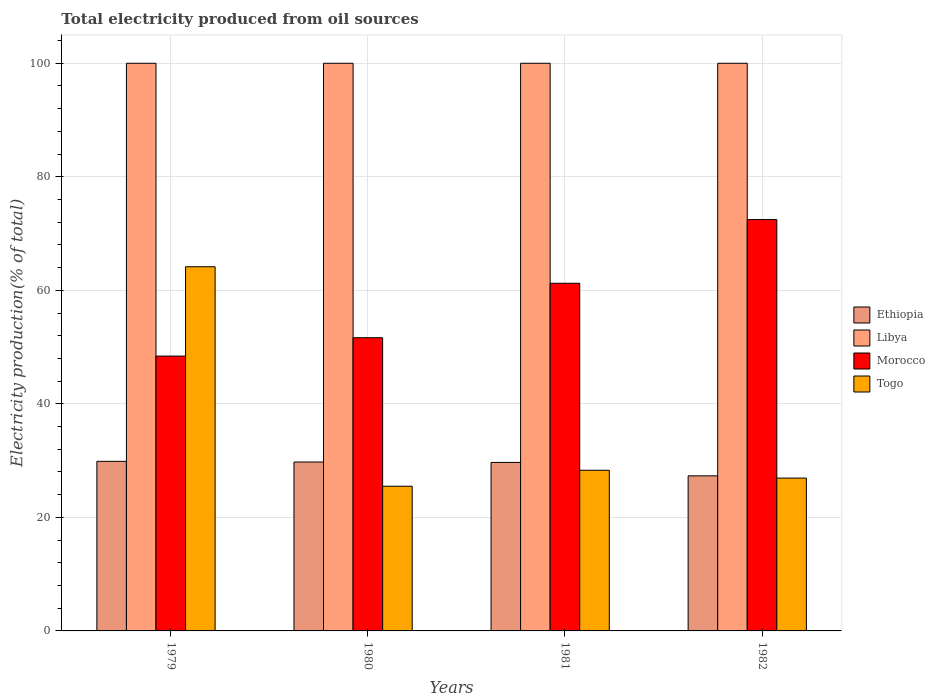How many different coloured bars are there?
Provide a short and direct response. 4. How many groups of bars are there?
Provide a short and direct response. 4. What is the label of the 3rd group of bars from the left?
Offer a terse response. 1981. What is the total electricity produced in Libya in 1980?
Make the answer very short. 100. Across all years, what is the minimum total electricity produced in Morocco?
Provide a succinct answer. 48.41. In which year was the total electricity produced in Togo maximum?
Give a very brief answer. 1979. In which year was the total electricity produced in Libya minimum?
Give a very brief answer. 1979. What is the total total electricity produced in Togo in the graph?
Your answer should be very brief. 144.87. What is the difference between the total electricity produced in Ethiopia in 1979 and that in 1980?
Provide a succinct answer. 0.12. What is the difference between the total electricity produced in Morocco in 1979 and the total electricity produced in Libya in 1980?
Ensure brevity in your answer.  -51.59. In the year 1982, what is the difference between the total electricity produced in Libya and total electricity produced in Togo?
Your answer should be very brief. 73.08. In how many years, is the total electricity produced in Togo greater than 20 %?
Your answer should be very brief. 4. What is the ratio of the total electricity produced in Ethiopia in 1981 to that in 1982?
Give a very brief answer. 1.09. Is the total electricity produced in Ethiopia in 1979 less than that in 1982?
Provide a short and direct response. No. In how many years, is the total electricity produced in Morocco greater than the average total electricity produced in Morocco taken over all years?
Offer a terse response. 2. Is it the case that in every year, the sum of the total electricity produced in Togo and total electricity produced in Ethiopia is greater than the sum of total electricity produced in Libya and total electricity produced in Morocco?
Give a very brief answer. No. What does the 1st bar from the left in 1979 represents?
Your answer should be compact. Ethiopia. What does the 4th bar from the right in 1980 represents?
Your answer should be compact. Ethiopia. How many bars are there?
Provide a succinct answer. 16. How many years are there in the graph?
Keep it short and to the point. 4. What is the difference between two consecutive major ticks on the Y-axis?
Provide a succinct answer. 20. How many legend labels are there?
Ensure brevity in your answer.  4. What is the title of the graph?
Your response must be concise. Total electricity produced from oil sources. What is the label or title of the Y-axis?
Offer a very short reply. Electricity production(% of total). What is the Electricity production(% of total) of Ethiopia in 1979?
Your answer should be very brief. 29.87. What is the Electricity production(% of total) in Libya in 1979?
Ensure brevity in your answer.  100. What is the Electricity production(% of total) of Morocco in 1979?
Your answer should be compact. 48.41. What is the Electricity production(% of total) in Togo in 1979?
Your answer should be very brief. 64.15. What is the Electricity production(% of total) in Ethiopia in 1980?
Ensure brevity in your answer.  29.75. What is the Electricity production(% of total) in Morocco in 1980?
Your answer should be compact. 51.65. What is the Electricity production(% of total) in Togo in 1980?
Offer a very short reply. 25.49. What is the Electricity production(% of total) in Ethiopia in 1981?
Provide a succinct answer. 29.68. What is the Electricity production(% of total) of Libya in 1981?
Offer a terse response. 100. What is the Electricity production(% of total) in Morocco in 1981?
Your answer should be very brief. 61.24. What is the Electricity production(% of total) in Togo in 1981?
Ensure brevity in your answer.  28.3. What is the Electricity production(% of total) of Ethiopia in 1982?
Provide a short and direct response. 27.32. What is the Electricity production(% of total) in Morocco in 1982?
Provide a short and direct response. 72.47. What is the Electricity production(% of total) in Togo in 1982?
Give a very brief answer. 26.92. Across all years, what is the maximum Electricity production(% of total) in Ethiopia?
Your answer should be very brief. 29.87. Across all years, what is the maximum Electricity production(% of total) of Libya?
Offer a very short reply. 100. Across all years, what is the maximum Electricity production(% of total) in Morocco?
Ensure brevity in your answer.  72.47. Across all years, what is the maximum Electricity production(% of total) of Togo?
Make the answer very short. 64.15. Across all years, what is the minimum Electricity production(% of total) in Ethiopia?
Provide a succinct answer. 27.32. Across all years, what is the minimum Electricity production(% of total) in Libya?
Your answer should be very brief. 100. Across all years, what is the minimum Electricity production(% of total) in Morocco?
Ensure brevity in your answer.  48.41. Across all years, what is the minimum Electricity production(% of total) in Togo?
Your answer should be very brief. 25.49. What is the total Electricity production(% of total) of Ethiopia in the graph?
Offer a very short reply. 116.62. What is the total Electricity production(% of total) of Morocco in the graph?
Offer a terse response. 233.77. What is the total Electricity production(% of total) of Togo in the graph?
Ensure brevity in your answer.  144.87. What is the difference between the Electricity production(% of total) in Ethiopia in 1979 and that in 1980?
Offer a terse response. 0.12. What is the difference between the Electricity production(% of total) in Libya in 1979 and that in 1980?
Give a very brief answer. 0. What is the difference between the Electricity production(% of total) of Morocco in 1979 and that in 1980?
Your response must be concise. -3.23. What is the difference between the Electricity production(% of total) in Togo in 1979 and that in 1980?
Your answer should be very brief. 38.66. What is the difference between the Electricity production(% of total) of Ethiopia in 1979 and that in 1981?
Your answer should be compact. 0.19. What is the difference between the Electricity production(% of total) of Libya in 1979 and that in 1981?
Provide a succinct answer. 0. What is the difference between the Electricity production(% of total) in Morocco in 1979 and that in 1981?
Your answer should be compact. -12.83. What is the difference between the Electricity production(% of total) in Togo in 1979 and that in 1981?
Your response must be concise. 35.85. What is the difference between the Electricity production(% of total) of Ethiopia in 1979 and that in 1982?
Keep it short and to the point. 2.55. What is the difference between the Electricity production(% of total) of Libya in 1979 and that in 1982?
Provide a succinct answer. 0. What is the difference between the Electricity production(% of total) in Morocco in 1979 and that in 1982?
Your answer should be very brief. -24.05. What is the difference between the Electricity production(% of total) of Togo in 1979 and that in 1982?
Your answer should be compact. 37.23. What is the difference between the Electricity production(% of total) in Ethiopia in 1980 and that in 1981?
Make the answer very short. 0.07. What is the difference between the Electricity production(% of total) in Libya in 1980 and that in 1981?
Your answer should be very brief. 0. What is the difference between the Electricity production(% of total) of Morocco in 1980 and that in 1981?
Make the answer very short. -9.59. What is the difference between the Electricity production(% of total) in Togo in 1980 and that in 1981?
Keep it short and to the point. -2.81. What is the difference between the Electricity production(% of total) of Ethiopia in 1980 and that in 1982?
Offer a terse response. 2.44. What is the difference between the Electricity production(% of total) in Libya in 1980 and that in 1982?
Your response must be concise. 0. What is the difference between the Electricity production(% of total) in Morocco in 1980 and that in 1982?
Provide a succinct answer. -20.82. What is the difference between the Electricity production(% of total) in Togo in 1980 and that in 1982?
Make the answer very short. -1.43. What is the difference between the Electricity production(% of total) of Ethiopia in 1981 and that in 1982?
Ensure brevity in your answer.  2.36. What is the difference between the Electricity production(% of total) of Libya in 1981 and that in 1982?
Ensure brevity in your answer.  0. What is the difference between the Electricity production(% of total) in Morocco in 1981 and that in 1982?
Provide a short and direct response. -11.22. What is the difference between the Electricity production(% of total) in Togo in 1981 and that in 1982?
Keep it short and to the point. 1.38. What is the difference between the Electricity production(% of total) in Ethiopia in 1979 and the Electricity production(% of total) in Libya in 1980?
Provide a succinct answer. -70.13. What is the difference between the Electricity production(% of total) of Ethiopia in 1979 and the Electricity production(% of total) of Morocco in 1980?
Your answer should be very brief. -21.78. What is the difference between the Electricity production(% of total) of Ethiopia in 1979 and the Electricity production(% of total) of Togo in 1980?
Make the answer very short. 4.38. What is the difference between the Electricity production(% of total) in Libya in 1979 and the Electricity production(% of total) in Morocco in 1980?
Make the answer very short. 48.35. What is the difference between the Electricity production(% of total) in Libya in 1979 and the Electricity production(% of total) in Togo in 1980?
Offer a very short reply. 74.51. What is the difference between the Electricity production(% of total) of Morocco in 1979 and the Electricity production(% of total) of Togo in 1980?
Your response must be concise. 22.92. What is the difference between the Electricity production(% of total) of Ethiopia in 1979 and the Electricity production(% of total) of Libya in 1981?
Your answer should be compact. -70.13. What is the difference between the Electricity production(% of total) in Ethiopia in 1979 and the Electricity production(% of total) in Morocco in 1981?
Your answer should be very brief. -31.37. What is the difference between the Electricity production(% of total) of Ethiopia in 1979 and the Electricity production(% of total) of Togo in 1981?
Provide a short and direct response. 1.57. What is the difference between the Electricity production(% of total) in Libya in 1979 and the Electricity production(% of total) in Morocco in 1981?
Offer a terse response. 38.76. What is the difference between the Electricity production(% of total) of Libya in 1979 and the Electricity production(% of total) of Togo in 1981?
Ensure brevity in your answer.  71.7. What is the difference between the Electricity production(% of total) of Morocco in 1979 and the Electricity production(% of total) of Togo in 1981?
Provide a short and direct response. 20.11. What is the difference between the Electricity production(% of total) of Ethiopia in 1979 and the Electricity production(% of total) of Libya in 1982?
Make the answer very short. -70.13. What is the difference between the Electricity production(% of total) of Ethiopia in 1979 and the Electricity production(% of total) of Morocco in 1982?
Keep it short and to the point. -42.59. What is the difference between the Electricity production(% of total) in Ethiopia in 1979 and the Electricity production(% of total) in Togo in 1982?
Provide a succinct answer. 2.95. What is the difference between the Electricity production(% of total) in Libya in 1979 and the Electricity production(% of total) in Morocco in 1982?
Make the answer very short. 27.53. What is the difference between the Electricity production(% of total) of Libya in 1979 and the Electricity production(% of total) of Togo in 1982?
Offer a terse response. 73.08. What is the difference between the Electricity production(% of total) of Morocco in 1979 and the Electricity production(% of total) of Togo in 1982?
Provide a succinct answer. 21.49. What is the difference between the Electricity production(% of total) in Ethiopia in 1980 and the Electricity production(% of total) in Libya in 1981?
Keep it short and to the point. -70.25. What is the difference between the Electricity production(% of total) in Ethiopia in 1980 and the Electricity production(% of total) in Morocco in 1981?
Give a very brief answer. -31.49. What is the difference between the Electricity production(% of total) in Ethiopia in 1980 and the Electricity production(% of total) in Togo in 1981?
Offer a very short reply. 1.45. What is the difference between the Electricity production(% of total) in Libya in 1980 and the Electricity production(% of total) in Morocco in 1981?
Your response must be concise. 38.76. What is the difference between the Electricity production(% of total) in Libya in 1980 and the Electricity production(% of total) in Togo in 1981?
Offer a very short reply. 71.7. What is the difference between the Electricity production(% of total) in Morocco in 1980 and the Electricity production(% of total) in Togo in 1981?
Make the answer very short. 23.35. What is the difference between the Electricity production(% of total) in Ethiopia in 1980 and the Electricity production(% of total) in Libya in 1982?
Offer a terse response. -70.25. What is the difference between the Electricity production(% of total) in Ethiopia in 1980 and the Electricity production(% of total) in Morocco in 1982?
Provide a succinct answer. -42.71. What is the difference between the Electricity production(% of total) of Ethiopia in 1980 and the Electricity production(% of total) of Togo in 1982?
Provide a short and direct response. 2.83. What is the difference between the Electricity production(% of total) of Libya in 1980 and the Electricity production(% of total) of Morocco in 1982?
Provide a short and direct response. 27.53. What is the difference between the Electricity production(% of total) of Libya in 1980 and the Electricity production(% of total) of Togo in 1982?
Your answer should be compact. 73.08. What is the difference between the Electricity production(% of total) of Morocco in 1980 and the Electricity production(% of total) of Togo in 1982?
Offer a very short reply. 24.73. What is the difference between the Electricity production(% of total) in Ethiopia in 1981 and the Electricity production(% of total) in Libya in 1982?
Keep it short and to the point. -70.32. What is the difference between the Electricity production(% of total) in Ethiopia in 1981 and the Electricity production(% of total) in Morocco in 1982?
Provide a succinct answer. -42.78. What is the difference between the Electricity production(% of total) of Ethiopia in 1981 and the Electricity production(% of total) of Togo in 1982?
Your response must be concise. 2.76. What is the difference between the Electricity production(% of total) in Libya in 1981 and the Electricity production(% of total) in Morocco in 1982?
Give a very brief answer. 27.53. What is the difference between the Electricity production(% of total) in Libya in 1981 and the Electricity production(% of total) in Togo in 1982?
Your answer should be compact. 73.08. What is the difference between the Electricity production(% of total) of Morocco in 1981 and the Electricity production(% of total) of Togo in 1982?
Provide a succinct answer. 34.32. What is the average Electricity production(% of total) of Ethiopia per year?
Your answer should be very brief. 29.16. What is the average Electricity production(% of total) in Morocco per year?
Ensure brevity in your answer.  58.44. What is the average Electricity production(% of total) of Togo per year?
Your answer should be very brief. 36.22. In the year 1979, what is the difference between the Electricity production(% of total) in Ethiopia and Electricity production(% of total) in Libya?
Make the answer very short. -70.13. In the year 1979, what is the difference between the Electricity production(% of total) in Ethiopia and Electricity production(% of total) in Morocco?
Ensure brevity in your answer.  -18.54. In the year 1979, what is the difference between the Electricity production(% of total) of Ethiopia and Electricity production(% of total) of Togo?
Your response must be concise. -34.28. In the year 1979, what is the difference between the Electricity production(% of total) of Libya and Electricity production(% of total) of Morocco?
Keep it short and to the point. 51.59. In the year 1979, what is the difference between the Electricity production(% of total) of Libya and Electricity production(% of total) of Togo?
Provide a succinct answer. 35.85. In the year 1979, what is the difference between the Electricity production(% of total) of Morocco and Electricity production(% of total) of Togo?
Your answer should be compact. -15.74. In the year 1980, what is the difference between the Electricity production(% of total) of Ethiopia and Electricity production(% of total) of Libya?
Offer a very short reply. -70.25. In the year 1980, what is the difference between the Electricity production(% of total) of Ethiopia and Electricity production(% of total) of Morocco?
Your answer should be compact. -21.9. In the year 1980, what is the difference between the Electricity production(% of total) in Ethiopia and Electricity production(% of total) in Togo?
Offer a very short reply. 4.26. In the year 1980, what is the difference between the Electricity production(% of total) of Libya and Electricity production(% of total) of Morocco?
Your response must be concise. 48.35. In the year 1980, what is the difference between the Electricity production(% of total) of Libya and Electricity production(% of total) of Togo?
Make the answer very short. 74.51. In the year 1980, what is the difference between the Electricity production(% of total) of Morocco and Electricity production(% of total) of Togo?
Provide a short and direct response. 26.16. In the year 1981, what is the difference between the Electricity production(% of total) in Ethiopia and Electricity production(% of total) in Libya?
Your response must be concise. -70.32. In the year 1981, what is the difference between the Electricity production(% of total) in Ethiopia and Electricity production(% of total) in Morocco?
Offer a terse response. -31.56. In the year 1981, what is the difference between the Electricity production(% of total) in Ethiopia and Electricity production(% of total) in Togo?
Provide a short and direct response. 1.38. In the year 1981, what is the difference between the Electricity production(% of total) of Libya and Electricity production(% of total) of Morocco?
Keep it short and to the point. 38.76. In the year 1981, what is the difference between the Electricity production(% of total) in Libya and Electricity production(% of total) in Togo?
Your answer should be compact. 71.7. In the year 1981, what is the difference between the Electricity production(% of total) in Morocco and Electricity production(% of total) in Togo?
Offer a very short reply. 32.94. In the year 1982, what is the difference between the Electricity production(% of total) in Ethiopia and Electricity production(% of total) in Libya?
Your answer should be compact. -72.68. In the year 1982, what is the difference between the Electricity production(% of total) of Ethiopia and Electricity production(% of total) of Morocco?
Ensure brevity in your answer.  -45.15. In the year 1982, what is the difference between the Electricity production(% of total) of Ethiopia and Electricity production(% of total) of Togo?
Give a very brief answer. 0.4. In the year 1982, what is the difference between the Electricity production(% of total) in Libya and Electricity production(% of total) in Morocco?
Offer a terse response. 27.53. In the year 1982, what is the difference between the Electricity production(% of total) of Libya and Electricity production(% of total) of Togo?
Keep it short and to the point. 73.08. In the year 1982, what is the difference between the Electricity production(% of total) of Morocco and Electricity production(% of total) of Togo?
Give a very brief answer. 45.54. What is the ratio of the Electricity production(% of total) of Libya in 1979 to that in 1980?
Make the answer very short. 1. What is the ratio of the Electricity production(% of total) in Morocco in 1979 to that in 1980?
Provide a short and direct response. 0.94. What is the ratio of the Electricity production(% of total) in Togo in 1979 to that in 1980?
Provide a short and direct response. 2.52. What is the ratio of the Electricity production(% of total) of Ethiopia in 1979 to that in 1981?
Offer a very short reply. 1.01. What is the ratio of the Electricity production(% of total) of Morocco in 1979 to that in 1981?
Offer a very short reply. 0.79. What is the ratio of the Electricity production(% of total) in Togo in 1979 to that in 1981?
Your answer should be very brief. 2.27. What is the ratio of the Electricity production(% of total) in Ethiopia in 1979 to that in 1982?
Offer a terse response. 1.09. What is the ratio of the Electricity production(% of total) in Libya in 1979 to that in 1982?
Provide a succinct answer. 1. What is the ratio of the Electricity production(% of total) in Morocco in 1979 to that in 1982?
Make the answer very short. 0.67. What is the ratio of the Electricity production(% of total) of Togo in 1979 to that in 1982?
Your response must be concise. 2.38. What is the ratio of the Electricity production(% of total) of Libya in 1980 to that in 1981?
Make the answer very short. 1. What is the ratio of the Electricity production(% of total) in Morocco in 1980 to that in 1981?
Make the answer very short. 0.84. What is the ratio of the Electricity production(% of total) in Togo in 1980 to that in 1981?
Ensure brevity in your answer.  0.9. What is the ratio of the Electricity production(% of total) in Ethiopia in 1980 to that in 1982?
Give a very brief answer. 1.09. What is the ratio of the Electricity production(% of total) of Morocco in 1980 to that in 1982?
Ensure brevity in your answer.  0.71. What is the ratio of the Electricity production(% of total) in Togo in 1980 to that in 1982?
Your response must be concise. 0.95. What is the ratio of the Electricity production(% of total) in Ethiopia in 1981 to that in 1982?
Your response must be concise. 1.09. What is the ratio of the Electricity production(% of total) of Libya in 1981 to that in 1982?
Give a very brief answer. 1. What is the ratio of the Electricity production(% of total) of Morocco in 1981 to that in 1982?
Your response must be concise. 0.85. What is the ratio of the Electricity production(% of total) of Togo in 1981 to that in 1982?
Offer a very short reply. 1.05. What is the difference between the highest and the second highest Electricity production(% of total) of Ethiopia?
Offer a very short reply. 0.12. What is the difference between the highest and the second highest Electricity production(% of total) in Libya?
Give a very brief answer. 0. What is the difference between the highest and the second highest Electricity production(% of total) of Morocco?
Give a very brief answer. 11.22. What is the difference between the highest and the second highest Electricity production(% of total) of Togo?
Offer a very short reply. 35.85. What is the difference between the highest and the lowest Electricity production(% of total) of Ethiopia?
Provide a succinct answer. 2.55. What is the difference between the highest and the lowest Electricity production(% of total) of Libya?
Your answer should be very brief. 0. What is the difference between the highest and the lowest Electricity production(% of total) in Morocco?
Your answer should be very brief. 24.05. What is the difference between the highest and the lowest Electricity production(% of total) in Togo?
Your answer should be very brief. 38.66. 